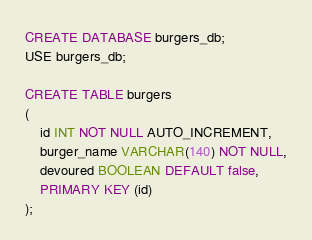<code> <loc_0><loc_0><loc_500><loc_500><_SQL_>CREATE DATABASE burgers_db;
USE burgers_db;

CREATE TABLE burgers
(
	id INT NOT NULL AUTO_INCREMENT,
	burger_name VARCHAR(140) NOT NULL,
	devoured BOOLEAN DEFAULT false,
	PRIMARY KEY (id)
);</code> 